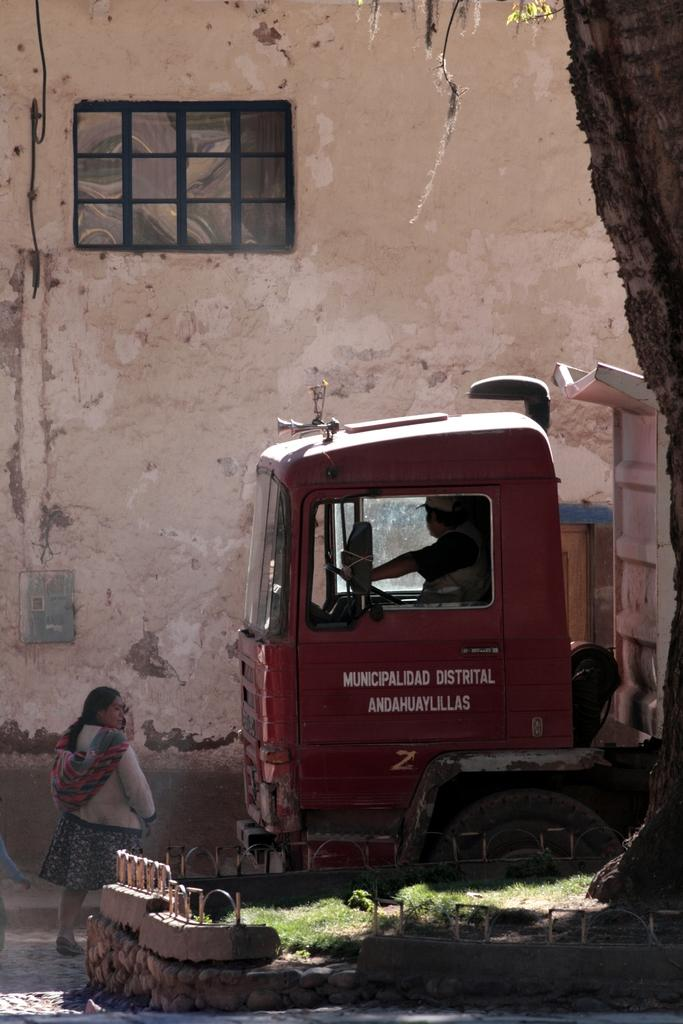What type of structure can be seen in the image? There is a wall in the image. What architectural feature is present in the wall? There is a window in the image. What type of vehicle is visible in the image? There is a truck in the image. What type of vegetation is present in the image? There is grass in the image. How many people are present in the image? There are two people in the image. What type of bead is being used by the birds to jump in the image? There are no beads or birds present in the image. How many times do the people jump in the image? The provided facts do not mention any jumping activity by the people in the image. 